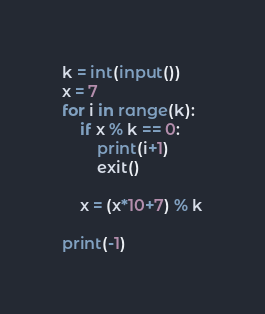Convert code to text. <code><loc_0><loc_0><loc_500><loc_500><_Python_>k = int(input())
x = 7
for i in range(k):
    if x % k == 0:
        print(i+1)
        exit()

    x = (x*10+7) % k

print(-1)
</code> 